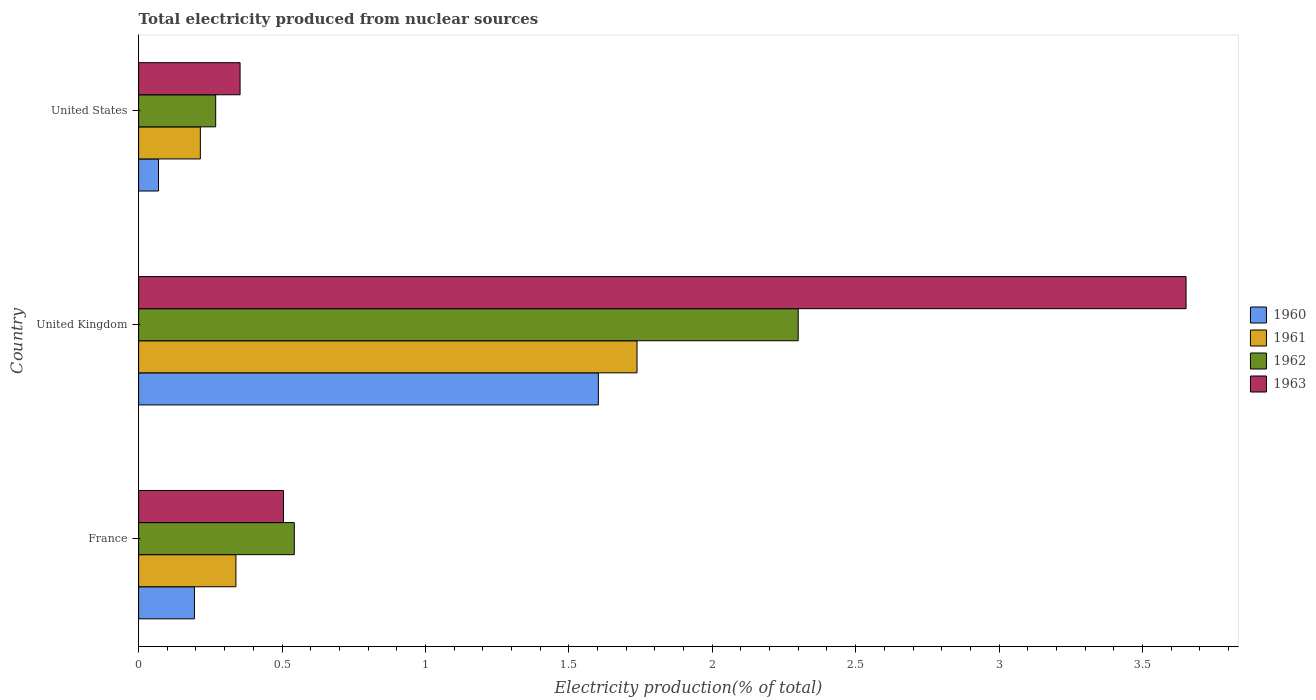How many groups of bars are there?
Your answer should be very brief. 3. Are the number of bars per tick equal to the number of legend labels?
Your response must be concise. Yes. Are the number of bars on each tick of the Y-axis equal?
Make the answer very short. Yes. What is the label of the 3rd group of bars from the top?
Your answer should be compact. France. What is the total electricity produced in 1961 in United Kingdom?
Your answer should be compact. 1.74. Across all countries, what is the maximum total electricity produced in 1961?
Provide a succinct answer. 1.74. Across all countries, what is the minimum total electricity produced in 1961?
Give a very brief answer. 0.22. In which country was the total electricity produced in 1961 maximum?
Offer a terse response. United Kingdom. In which country was the total electricity produced in 1960 minimum?
Offer a very short reply. United States. What is the total total electricity produced in 1963 in the graph?
Your answer should be very brief. 4.51. What is the difference between the total electricity produced in 1961 in France and that in United States?
Your answer should be very brief. 0.12. What is the difference between the total electricity produced in 1963 in United States and the total electricity produced in 1960 in France?
Your answer should be compact. 0.16. What is the average total electricity produced in 1961 per country?
Provide a short and direct response. 0.76. What is the difference between the total electricity produced in 1961 and total electricity produced in 1962 in United Kingdom?
Make the answer very short. -0.56. What is the ratio of the total electricity produced in 1962 in France to that in United Kingdom?
Keep it short and to the point. 0.24. Is the total electricity produced in 1961 in France less than that in United States?
Ensure brevity in your answer.  No. Is the difference between the total electricity produced in 1961 in United Kingdom and United States greater than the difference between the total electricity produced in 1962 in United Kingdom and United States?
Keep it short and to the point. No. What is the difference between the highest and the second highest total electricity produced in 1963?
Your response must be concise. 3.15. What is the difference between the highest and the lowest total electricity produced in 1961?
Your answer should be very brief. 1.52. In how many countries, is the total electricity produced in 1961 greater than the average total electricity produced in 1961 taken over all countries?
Give a very brief answer. 1. Is the sum of the total electricity produced in 1961 in France and United States greater than the maximum total electricity produced in 1962 across all countries?
Provide a short and direct response. No. Is it the case that in every country, the sum of the total electricity produced in 1962 and total electricity produced in 1961 is greater than the sum of total electricity produced in 1963 and total electricity produced in 1960?
Offer a terse response. No. How many bars are there?
Your answer should be compact. 12. How many countries are there in the graph?
Your answer should be very brief. 3. What is the difference between two consecutive major ticks on the X-axis?
Provide a succinct answer. 0.5. Does the graph contain grids?
Give a very brief answer. No. Where does the legend appear in the graph?
Offer a very short reply. Center right. How many legend labels are there?
Your answer should be compact. 4. How are the legend labels stacked?
Give a very brief answer. Vertical. What is the title of the graph?
Offer a terse response. Total electricity produced from nuclear sources. Does "2010" appear as one of the legend labels in the graph?
Keep it short and to the point. No. What is the label or title of the Y-axis?
Make the answer very short. Country. What is the Electricity production(% of total) of 1960 in France?
Provide a short and direct response. 0.19. What is the Electricity production(% of total) in 1961 in France?
Offer a terse response. 0.34. What is the Electricity production(% of total) of 1962 in France?
Offer a terse response. 0.54. What is the Electricity production(% of total) in 1963 in France?
Keep it short and to the point. 0.51. What is the Electricity production(% of total) of 1960 in United Kingdom?
Ensure brevity in your answer.  1.6. What is the Electricity production(% of total) of 1961 in United Kingdom?
Make the answer very short. 1.74. What is the Electricity production(% of total) of 1962 in United Kingdom?
Your answer should be compact. 2.3. What is the Electricity production(% of total) in 1963 in United Kingdom?
Offer a terse response. 3.65. What is the Electricity production(% of total) of 1960 in United States?
Provide a succinct answer. 0.07. What is the Electricity production(% of total) of 1961 in United States?
Make the answer very short. 0.22. What is the Electricity production(% of total) in 1962 in United States?
Your answer should be very brief. 0.27. What is the Electricity production(% of total) of 1963 in United States?
Make the answer very short. 0.35. Across all countries, what is the maximum Electricity production(% of total) in 1960?
Keep it short and to the point. 1.6. Across all countries, what is the maximum Electricity production(% of total) of 1961?
Offer a very short reply. 1.74. Across all countries, what is the maximum Electricity production(% of total) in 1962?
Provide a short and direct response. 2.3. Across all countries, what is the maximum Electricity production(% of total) of 1963?
Ensure brevity in your answer.  3.65. Across all countries, what is the minimum Electricity production(% of total) of 1960?
Your response must be concise. 0.07. Across all countries, what is the minimum Electricity production(% of total) in 1961?
Ensure brevity in your answer.  0.22. Across all countries, what is the minimum Electricity production(% of total) in 1962?
Provide a short and direct response. 0.27. Across all countries, what is the minimum Electricity production(% of total) of 1963?
Give a very brief answer. 0.35. What is the total Electricity production(% of total) in 1960 in the graph?
Your response must be concise. 1.87. What is the total Electricity production(% of total) in 1961 in the graph?
Your response must be concise. 2.29. What is the total Electricity production(% of total) of 1962 in the graph?
Provide a succinct answer. 3.11. What is the total Electricity production(% of total) of 1963 in the graph?
Offer a terse response. 4.51. What is the difference between the Electricity production(% of total) of 1960 in France and that in United Kingdom?
Provide a short and direct response. -1.41. What is the difference between the Electricity production(% of total) in 1961 in France and that in United Kingdom?
Provide a short and direct response. -1.4. What is the difference between the Electricity production(% of total) of 1962 in France and that in United Kingdom?
Give a very brief answer. -1.76. What is the difference between the Electricity production(% of total) in 1963 in France and that in United Kingdom?
Provide a succinct answer. -3.15. What is the difference between the Electricity production(% of total) of 1960 in France and that in United States?
Keep it short and to the point. 0.13. What is the difference between the Electricity production(% of total) of 1961 in France and that in United States?
Keep it short and to the point. 0.12. What is the difference between the Electricity production(% of total) of 1962 in France and that in United States?
Your answer should be compact. 0.27. What is the difference between the Electricity production(% of total) in 1963 in France and that in United States?
Keep it short and to the point. 0.15. What is the difference between the Electricity production(% of total) of 1960 in United Kingdom and that in United States?
Provide a succinct answer. 1.53. What is the difference between the Electricity production(% of total) of 1961 in United Kingdom and that in United States?
Offer a very short reply. 1.52. What is the difference between the Electricity production(% of total) of 1962 in United Kingdom and that in United States?
Ensure brevity in your answer.  2.03. What is the difference between the Electricity production(% of total) of 1963 in United Kingdom and that in United States?
Ensure brevity in your answer.  3.3. What is the difference between the Electricity production(% of total) of 1960 in France and the Electricity production(% of total) of 1961 in United Kingdom?
Make the answer very short. -1.54. What is the difference between the Electricity production(% of total) in 1960 in France and the Electricity production(% of total) in 1962 in United Kingdom?
Ensure brevity in your answer.  -2.11. What is the difference between the Electricity production(% of total) in 1960 in France and the Electricity production(% of total) in 1963 in United Kingdom?
Offer a terse response. -3.46. What is the difference between the Electricity production(% of total) of 1961 in France and the Electricity production(% of total) of 1962 in United Kingdom?
Your answer should be compact. -1.96. What is the difference between the Electricity production(% of total) in 1961 in France and the Electricity production(% of total) in 1963 in United Kingdom?
Offer a terse response. -3.31. What is the difference between the Electricity production(% of total) in 1962 in France and the Electricity production(% of total) in 1963 in United Kingdom?
Ensure brevity in your answer.  -3.11. What is the difference between the Electricity production(% of total) of 1960 in France and the Electricity production(% of total) of 1961 in United States?
Keep it short and to the point. -0.02. What is the difference between the Electricity production(% of total) in 1960 in France and the Electricity production(% of total) in 1962 in United States?
Your response must be concise. -0.07. What is the difference between the Electricity production(% of total) of 1960 in France and the Electricity production(% of total) of 1963 in United States?
Provide a succinct answer. -0.16. What is the difference between the Electricity production(% of total) in 1961 in France and the Electricity production(% of total) in 1962 in United States?
Give a very brief answer. 0.07. What is the difference between the Electricity production(% of total) of 1961 in France and the Electricity production(% of total) of 1963 in United States?
Offer a terse response. -0.01. What is the difference between the Electricity production(% of total) in 1962 in France and the Electricity production(% of total) in 1963 in United States?
Offer a terse response. 0.19. What is the difference between the Electricity production(% of total) of 1960 in United Kingdom and the Electricity production(% of total) of 1961 in United States?
Make the answer very short. 1.39. What is the difference between the Electricity production(% of total) in 1960 in United Kingdom and the Electricity production(% of total) in 1962 in United States?
Provide a succinct answer. 1.33. What is the difference between the Electricity production(% of total) in 1960 in United Kingdom and the Electricity production(% of total) in 1963 in United States?
Your answer should be very brief. 1.25. What is the difference between the Electricity production(% of total) in 1961 in United Kingdom and the Electricity production(% of total) in 1962 in United States?
Offer a very short reply. 1.47. What is the difference between the Electricity production(% of total) in 1961 in United Kingdom and the Electricity production(% of total) in 1963 in United States?
Keep it short and to the point. 1.38. What is the difference between the Electricity production(% of total) in 1962 in United Kingdom and the Electricity production(% of total) in 1963 in United States?
Offer a very short reply. 1.95. What is the average Electricity production(% of total) in 1960 per country?
Keep it short and to the point. 0.62. What is the average Electricity production(% of total) in 1961 per country?
Ensure brevity in your answer.  0.76. What is the average Electricity production(% of total) in 1962 per country?
Keep it short and to the point. 1.04. What is the average Electricity production(% of total) of 1963 per country?
Your answer should be compact. 1.5. What is the difference between the Electricity production(% of total) in 1960 and Electricity production(% of total) in 1961 in France?
Your answer should be very brief. -0.14. What is the difference between the Electricity production(% of total) in 1960 and Electricity production(% of total) in 1962 in France?
Provide a succinct answer. -0.35. What is the difference between the Electricity production(% of total) in 1960 and Electricity production(% of total) in 1963 in France?
Your response must be concise. -0.31. What is the difference between the Electricity production(% of total) in 1961 and Electricity production(% of total) in 1962 in France?
Provide a short and direct response. -0.2. What is the difference between the Electricity production(% of total) in 1961 and Electricity production(% of total) in 1963 in France?
Ensure brevity in your answer.  -0.17. What is the difference between the Electricity production(% of total) in 1962 and Electricity production(% of total) in 1963 in France?
Offer a very short reply. 0.04. What is the difference between the Electricity production(% of total) of 1960 and Electricity production(% of total) of 1961 in United Kingdom?
Your answer should be compact. -0.13. What is the difference between the Electricity production(% of total) in 1960 and Electricity production(% of total) in 1962 in United Kingdom?
Provide a short and direct response. -0.7. What is the difference between the Electricity production(% of total) of 1960 and Electricity production(% of total) of 1963 in United Kingdom?
Offer a terse response. -2.05. What is the difference between the Electricity production(% of total) of 1961 and Electricity production(% of total) of 1962 in United Kingdom?
Your response must be concise. -0.56. What is the difference between the Electricity production(% of total) of 1961 and Electricity production(% of total) of 1963 in United Kingdom?
Your answer should be compact. -1.91. What is the difference between the Electricity production(% of total) of 1962 and Electricity production(% of total) of 1963 in United Kingdom?
Make the answer very short. -1.35. What is the difference between the Electricity production(% of total) in 1960 and Electricity production(% of total) in 1961 in United States?
Provide a succinct answer. -0.15. What is the difference between the Electricity production(% of total) of 1960 and Electricity production(% of total) of 1962 in United States?
Your answer should be very brief. -0.2. What is the difference between the Electricity production(% of total) of 1960 and Electricity production(% of total) of 1963 in United States?
Your answer should be compact. -0.28. What is the difference between the Electricity production(% of total) of 1961 and Electricity production(% of total) of 1962 in United States?
Ensure brevity in your answer.  -0.05. What is the difference between the Electricity production(% of total) in 1961 and Electricity production(% of total) in 1963 in United States?
Give a very brief answer. -0.14. What is the difference between the Electricity production(% of total) of 1962 and Electricity production(% of total) of 1963 in United States?
Give a very brief answer. -0.09. What is the ratio of the Electricity production(% of total) in 1960 in France to that in United Kingdom?
Offer a very short reply. 0.12. What is the ratio of the Electricity production(% of total) in 1961 in France to that in United Kingdom?
Ensure brevity in your answer.  0.2. What is the ratio of the Electricity production(% of total) of 1962 in France to that in United Kingdom?
Give a very brief answer. 0.24. What is the ratio of the Electricity production(% of total) of 1963 in France to that in United Kingdom?
Offer a terse response. 0.14. What is the ratio of the Electricity production(% of total) in 1960 in France to that in United States?
Your answer should be very brief. 2.81. What is the ratio of the Electricity production(% of total) of 1961 in France to that in United States?
Make the answer very short. 1.58. What is the ratio of the Electricity production(% of total) of 1962 in France to that in United States?
Ensure brevity in your answer.  2.02. What is the ratio of the Electricity production(% of total) in 1963 in France to that in United States?
Keep it short and to the point. 1.43. What is the ratio of the Electricity production(% of total) in 1960 in United Kingdom to that in United States?
Provide a succinct answer. 23.14. What is the ratio of the Electricity production(% of total) of 1961 in United Kingdom to that in United States?
Ensure brevity in your answer.  8.08. What is the ratio of the Electricity production(% of total) in 1962 in United Kingdom to that in United States?
Provide a short and direct response. 8.56. What is the ratio of the Electricity production(% of total) of 1963 in United Kingdom to that in United States?
Give a very brief answer. 10.32. What is the difference between the highest and the second highest Electricity production(% of total) of 1960?
Your response must be concise. 1.41. What is the difference between the highest and the second highest Electricity production(% of total) in 1961?
Keep it short and to the point. 1.4. What is the difference between the highest and the second highest Electricity production(% of total) of 1962?
Your answer should be very brief. 1.76. What is the difference between the highest and the second highest Electricity production(% of total) of 1963?
Make the answer very short. 3.15. What is the difference between the highest and the lowest Electricity production(% of total) of 1960?
Give a very brief answer. 1.53. What is the difference between the highest and the lowest Electricity production(% of total) in 1961?
Your answer should be very brief. 1.52. What is the difference between the highest and the lowest Electricity production(% of total) of 1962?
Your answer should be compact. 2.03. What is the difference between the highest and the lowest Electricity production(% of total) in 1963?
Give a very brief answer. 3.3. 